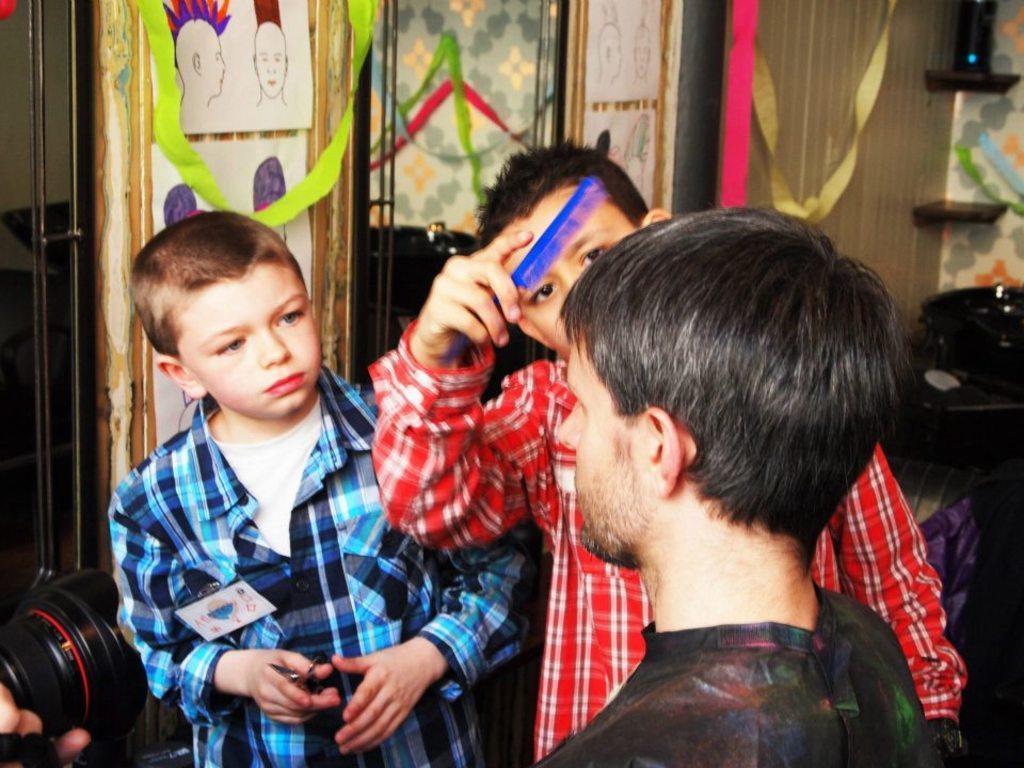Describe this image in one or two sentences. This is a picture where there are 3 persons standing near the camera and at the back ground we have paper ribbons , frames attached to the wall, and a couch. 